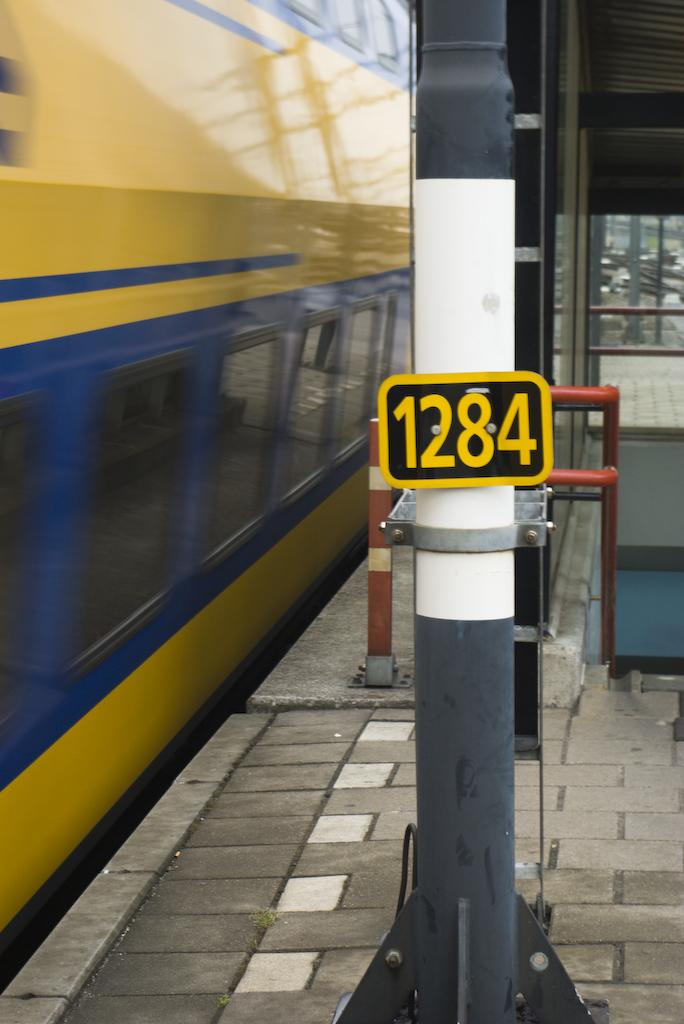Provide a one-sentence caption for the provided image. The side of a yellow and blue train going by a sign reading 1284. 